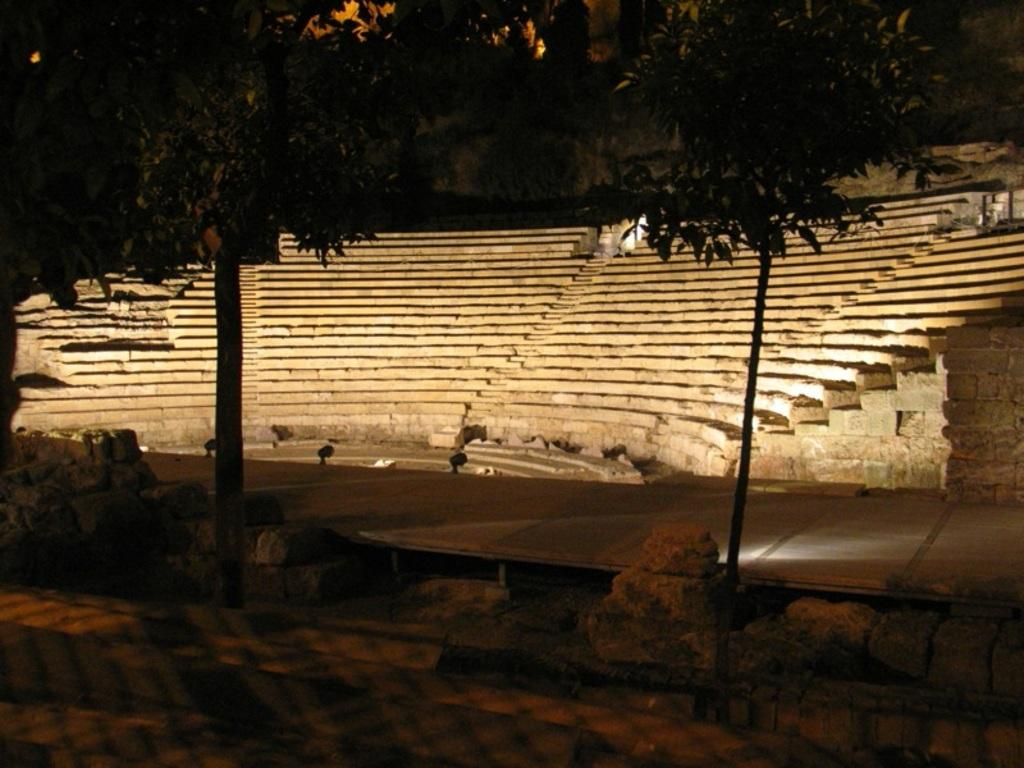What type of structure is visible in the image? There is a staircase in the image. What natural elements can be seen in the image? There are trees in the image. What man-made feature is present in the image? There is a road in the image. Where is the jail located in the image? There is no jail present in the image. What type of farm animals can be seen grazing in the image? There are no farm animals present in the image. 